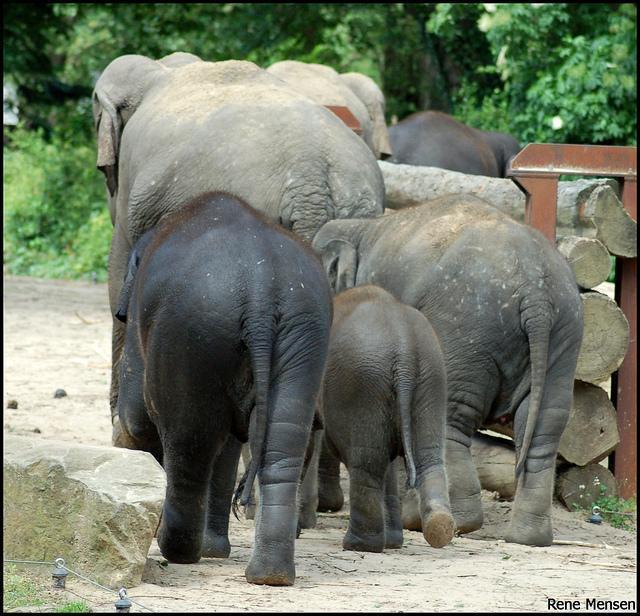How many elephants are there?
Give a very brief answer. 5. How many elephants are in this picture?
Give a very brief answer. 6. How many elephants are in the picture?
Give a very brief answer. 6. 